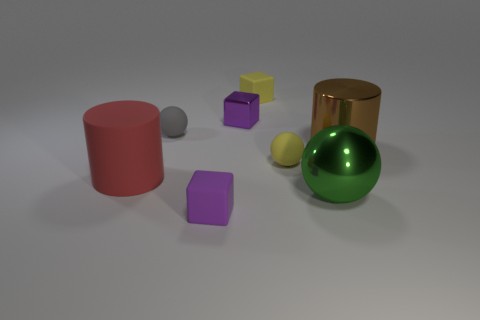Subtract all tiny rubber spheres. How many spheres are left? 1 Add 2 big green metal objects. How many objects exist? 10 Subtract all spheres. How many objects are left? 5 Subtract 2 spheres. How many spheres are left? 1 Subtract all cyan blocks. Subtract all purple cylinders. How many blocks are left? 3 Subtract all purple blocks. How many red cylinders are left? 1 Subtract all big green objects. Subtract all purple cylinders. How many objects are left? 7 Add 3 big brown objects. How many big brown objects are left? 4 Add 1 small purple blocks. How many small purple blocks exist? 3 Subtract all green balls. How many balls are left? 2 